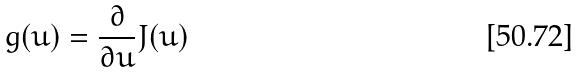<formula> <loc_0><loc_0><loc_500><loc_500>g ( u ) = \frac { \partial } { \partial u } J ( u )</formula> 